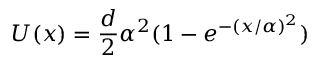Convert formula to latex. <formula><loc_0><loc_0><loc_500><loc_500>U ( x ) = { \frac { d } { 2 } } \alpha ^ { 2 } ( 1 - e ^ { - ( x / \alpha ) ^ { 2 } } )</formula> 